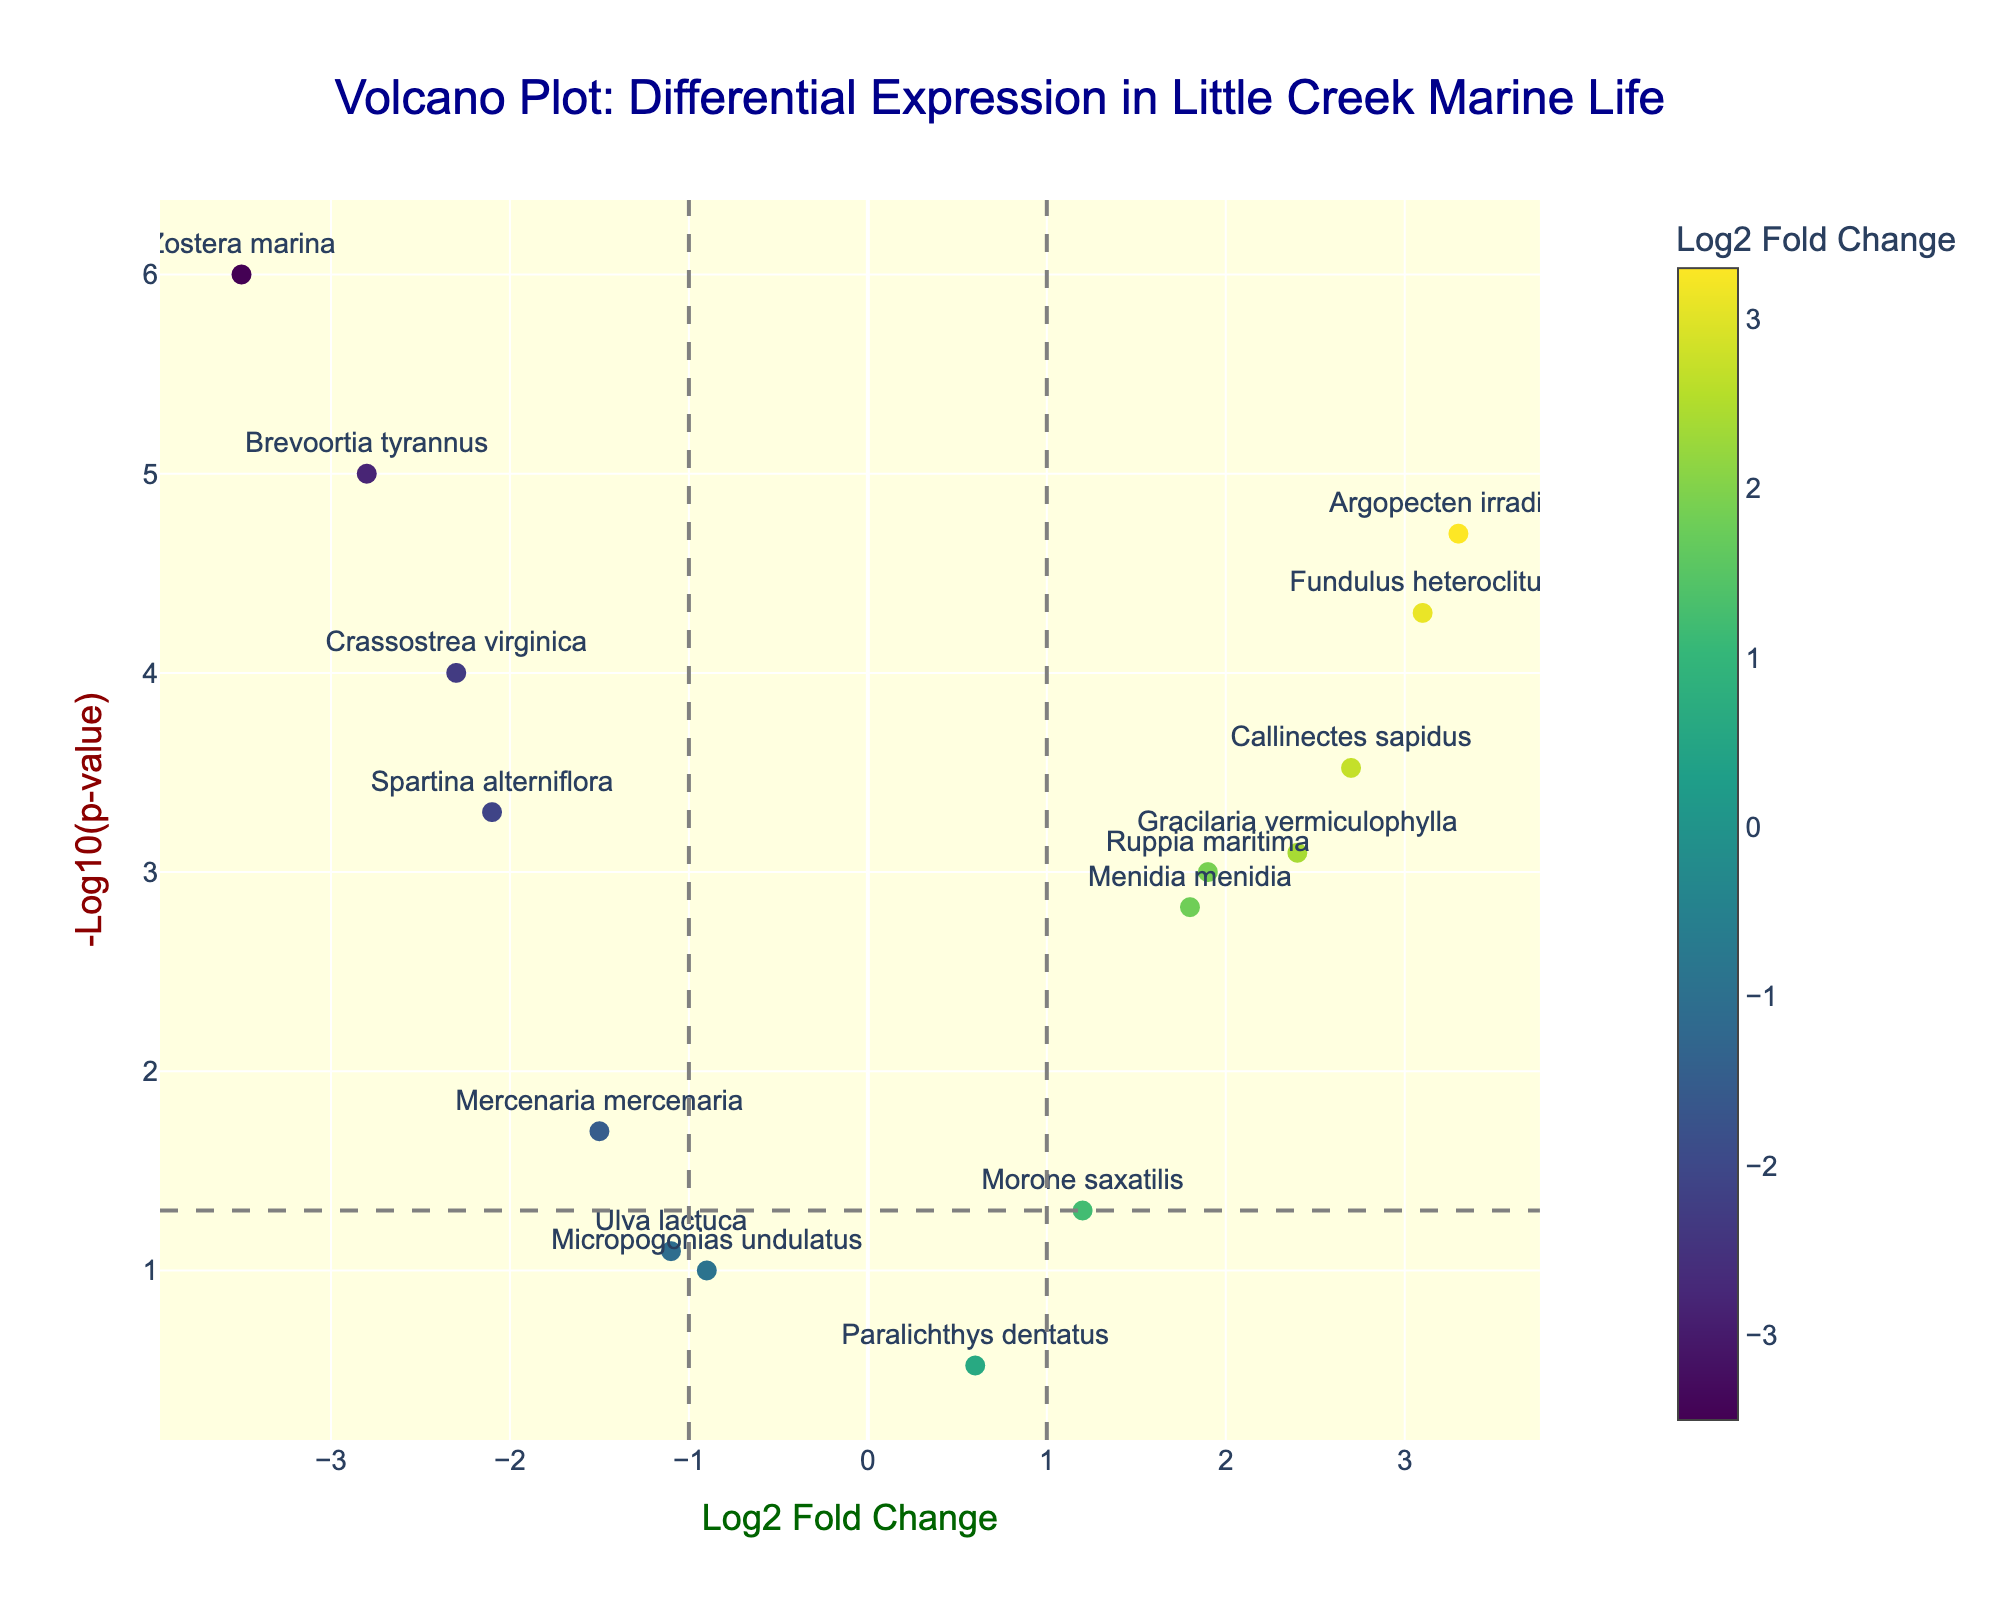What's the title of the plot? The title is prominently displayed at the top of the plot.
Answer: Volcano Plot: Differential Expression in Little Creek Marine Life What does the y-axis represent? The y-axis title clearly states that it represents the -Log10(p-value).
Answer: -Log10(p-value) How many navy-blue colored points are there in the plot? There is a colorbar indicating the color represents Log2 Fold Change. Navy-blue corresponds to a lower Log2 Fold Change. Counting these points visually yields the answer.
Answer: 7 Which species has the highest Log2 Fold Change? Observe the plotted points and locate the one farthest to the right. The hover text or labels show that "Argopecten irradians" has the highest Log2 Fold Change.
Answer: Argopecten irradians Which two species have the most significant changes (smallest p-values)? The most significant changes are represented by the highest points (because -log10(p-value) is highest). These correspond to "Zostera marina" and "Brevoortia tyrannus".
Answer: Zostera marina, Brevoortia tyrannus Is there a species with a Log2 Fold Change around 0.6 that is significant? According to the plot, "Paralichthys dentatus" has a Log2 Fold Change around 0.6. However, it is above the significance threshold line at -log10(0.05).
Answer: No Are there any species with a Log2 Fold Change greater than 3? By checking the plot, any species with x-axis values greater than 3 are targeted. "Fundulus heteroclitus" and "Argopecten irradians" have Log2 Fold Change greater than 3.
Answer: Yes What distinguishes "Ulva lactuca" in terms of significance and Log2 Fold Change? "Ulva lactuca" has a Log2 Fold Change around -1.1 and is above the significance threshold, making it non-significant.
Answer: Non-significant and Log2 Fold Change around -1.1 How many genes have a negative Log2 Fold Change and significant p-value? Points left of the y-axis (negative Log2 Fold Change) and above the significance threshold are counted: "Crassostrea virginica", "Mercenaria mercenaria", "Brevoortia tyrannus", "Zostera marina", and "Spartina alterniflora".
Answer: 5 